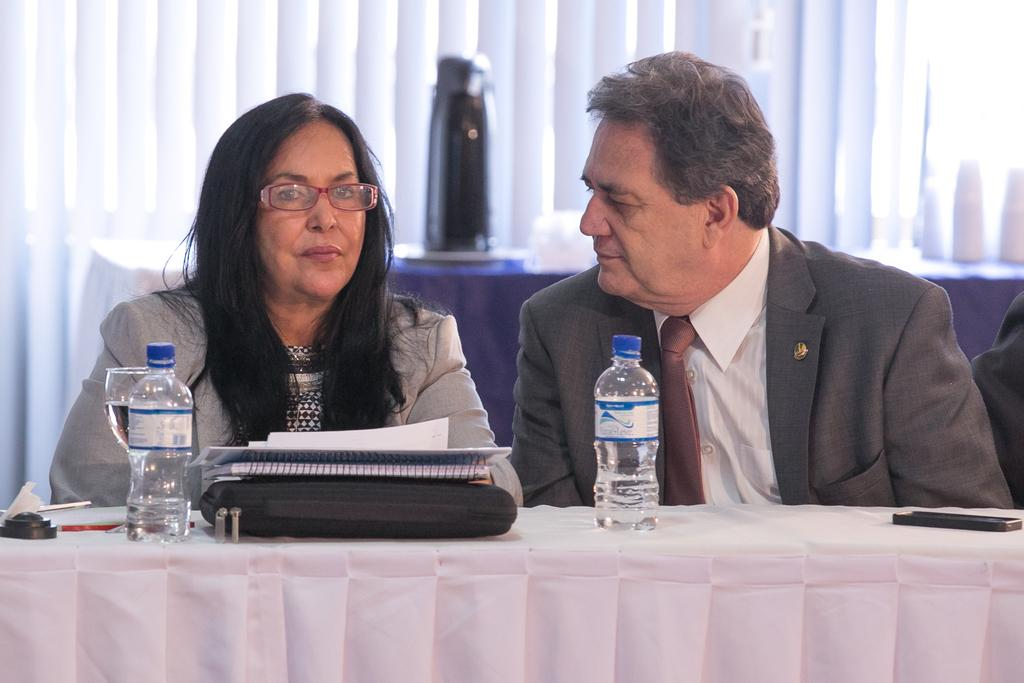How many people are in the image? There are two persons in the image. What are the persons wearing? The persons are wearing clothes. Where are the persons sitting in relation to the table? The persons are sitting in front of the table. What items can be seen on the table? The table contains bottles, a glass, a bag, and books. What is located at the top of the image? There is a flask at the top of the image. What type of farm animals can be seen in the image? There are no farm animals present in the image. What color is the lead object in the image? There is no lead object present in the image. 